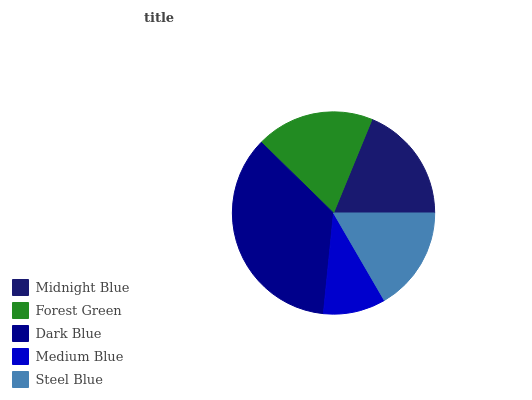Is Medium Blue the minimum?
Answer yes or no. Yes. Is Dark Blue the maximum?
Answer yes or no. Yes. Is Forest Green the minimum?
Answer yes or no. No. Is Forest Green the maximum?
Answer yes or no. No. Is Forest Green greater than Midnight Blue?
Answer yes or no. Yes. Is Midnight Blue less than Forest Green?
Answer yes or no. Yes. Is Midnight Blue greater than Forest Green?
Answer yes or no. No. Is Forest Green less than Midnight Blue?
Answer yes or no. No. Is Midnight Blue the high median?
Answer yes or no. Yes. Is Midnight Blue the low median?
Answer yes or no. Yes. Is Medium Blue the high median?
Answer yes or no. No. Is Medium Blue the low median?
Answer yes or no. No. 